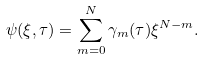<formula> <loc_0><loc_0><loc_500><loc_500>\psi ( \xi , \tau ) = \sum ^ { N } _ { m = 0 } \gamma _ { m } ( \tau ) \xi ^ { N - m } .</formula> 